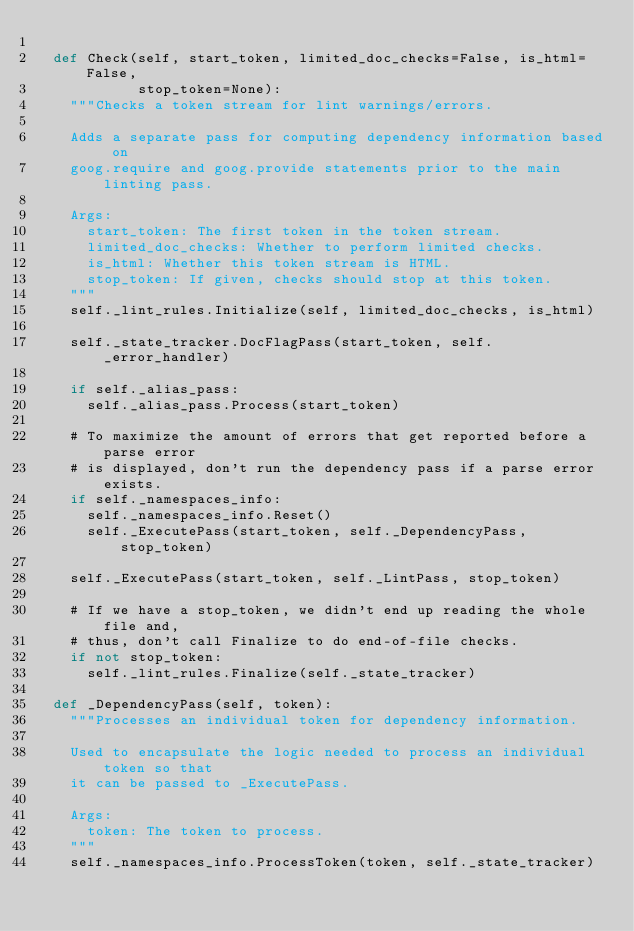<code> <loc_0><loc_0><loc_500><loc_500><_Python_>
  def Check(self, start_token, limited_doc_checks=False, is_html=False,
            stop_token=None):
    """Checks a token stream for lint warnings/errors.

    Adds a separate pass for computing dependency information based on
    goog.require and goog.provide statements prior to the main linting pass.

    Args:
      start_token: The first token in the token stream.
      limited_doc_checks: Whether to perform limited checks.
      is_html: Whether this token stream is HTML.
      stop_token: If given, checks should stop at this token.
    """
    self._lint_rules.Initialize(self, limited_doc_checks, is_html)

    self._state_tracker.DocFlagPass(start_token, self._error_handler)

    if self._alias_pass:
      self._alias_pass.Process(start_token)

    # To maximize the amount of errors that get reported before a parse error
    # is displayed, don't run the dependency pass if a parse error exists.
    if self._namespaces_info:
      self._namespaces_info.Reset()
      self._ExecutePass(start_token, self._DependencyPass, stop_token)

    self._ExecutePass(start_token, self._LintPass, stop_token)

    # If we have a stop_token, we didn't end up reading the whole file and,
    # thus, don't call Finalize to do end-of-file checks.
    if not stop_token:
      self._lint_rules.Finalize(self._state_tracker)

  def _DependencyPass(self, token):
    """Processes an individual token for dependency information.

    Used to encapsulate the logic needed to process an individual token so that
    it can be passed to _ExecutePass.

    Args:
      token: The token to process.
    """
    self._namespaces_info.ProcessToken(token, self._state_tracker)
</code> 